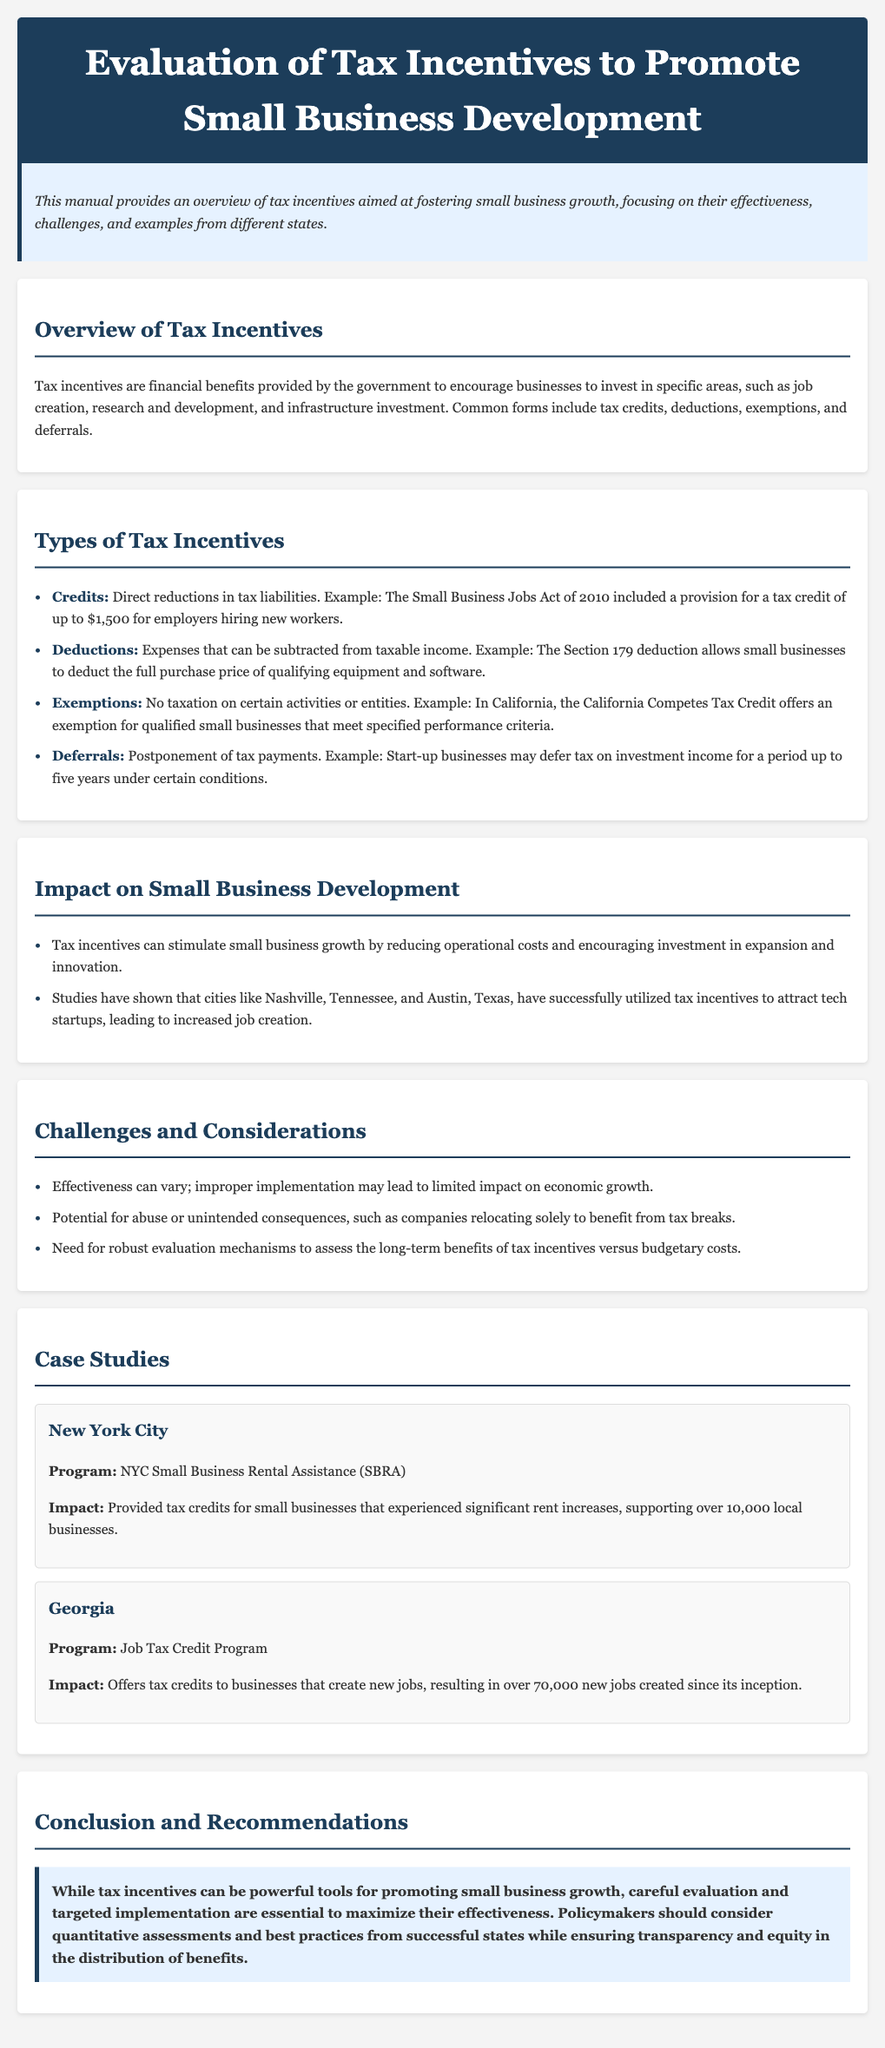What are tax incentives? Tax incentives are financial benefits provided by the government to encourage businesses to invest in specific areas.
Answer: Financial benefits What is an example of a credit? The Small Business Jobs Act of 2010 included a provision for a tax credit of up to $1,500 for employers hiring new workers.
Answer: Tax credit of up to $1,500 How many local businesses did NYC's Small Business Rental Assistance program support? The program supported over 10,000 local businesses.
Answer: Over 10,000 What is a challenge of tax incentives mentioned in the document? Effectiveness can vary; improper implementation may lead to limited impact on economic growth.
Answer: Effectiveness can vary What should policymakers consider when implementing tax incentives? Policymakers should consider quantitative assessments and best practices from successful states.
Answer: Quantitative assessments and best practices 